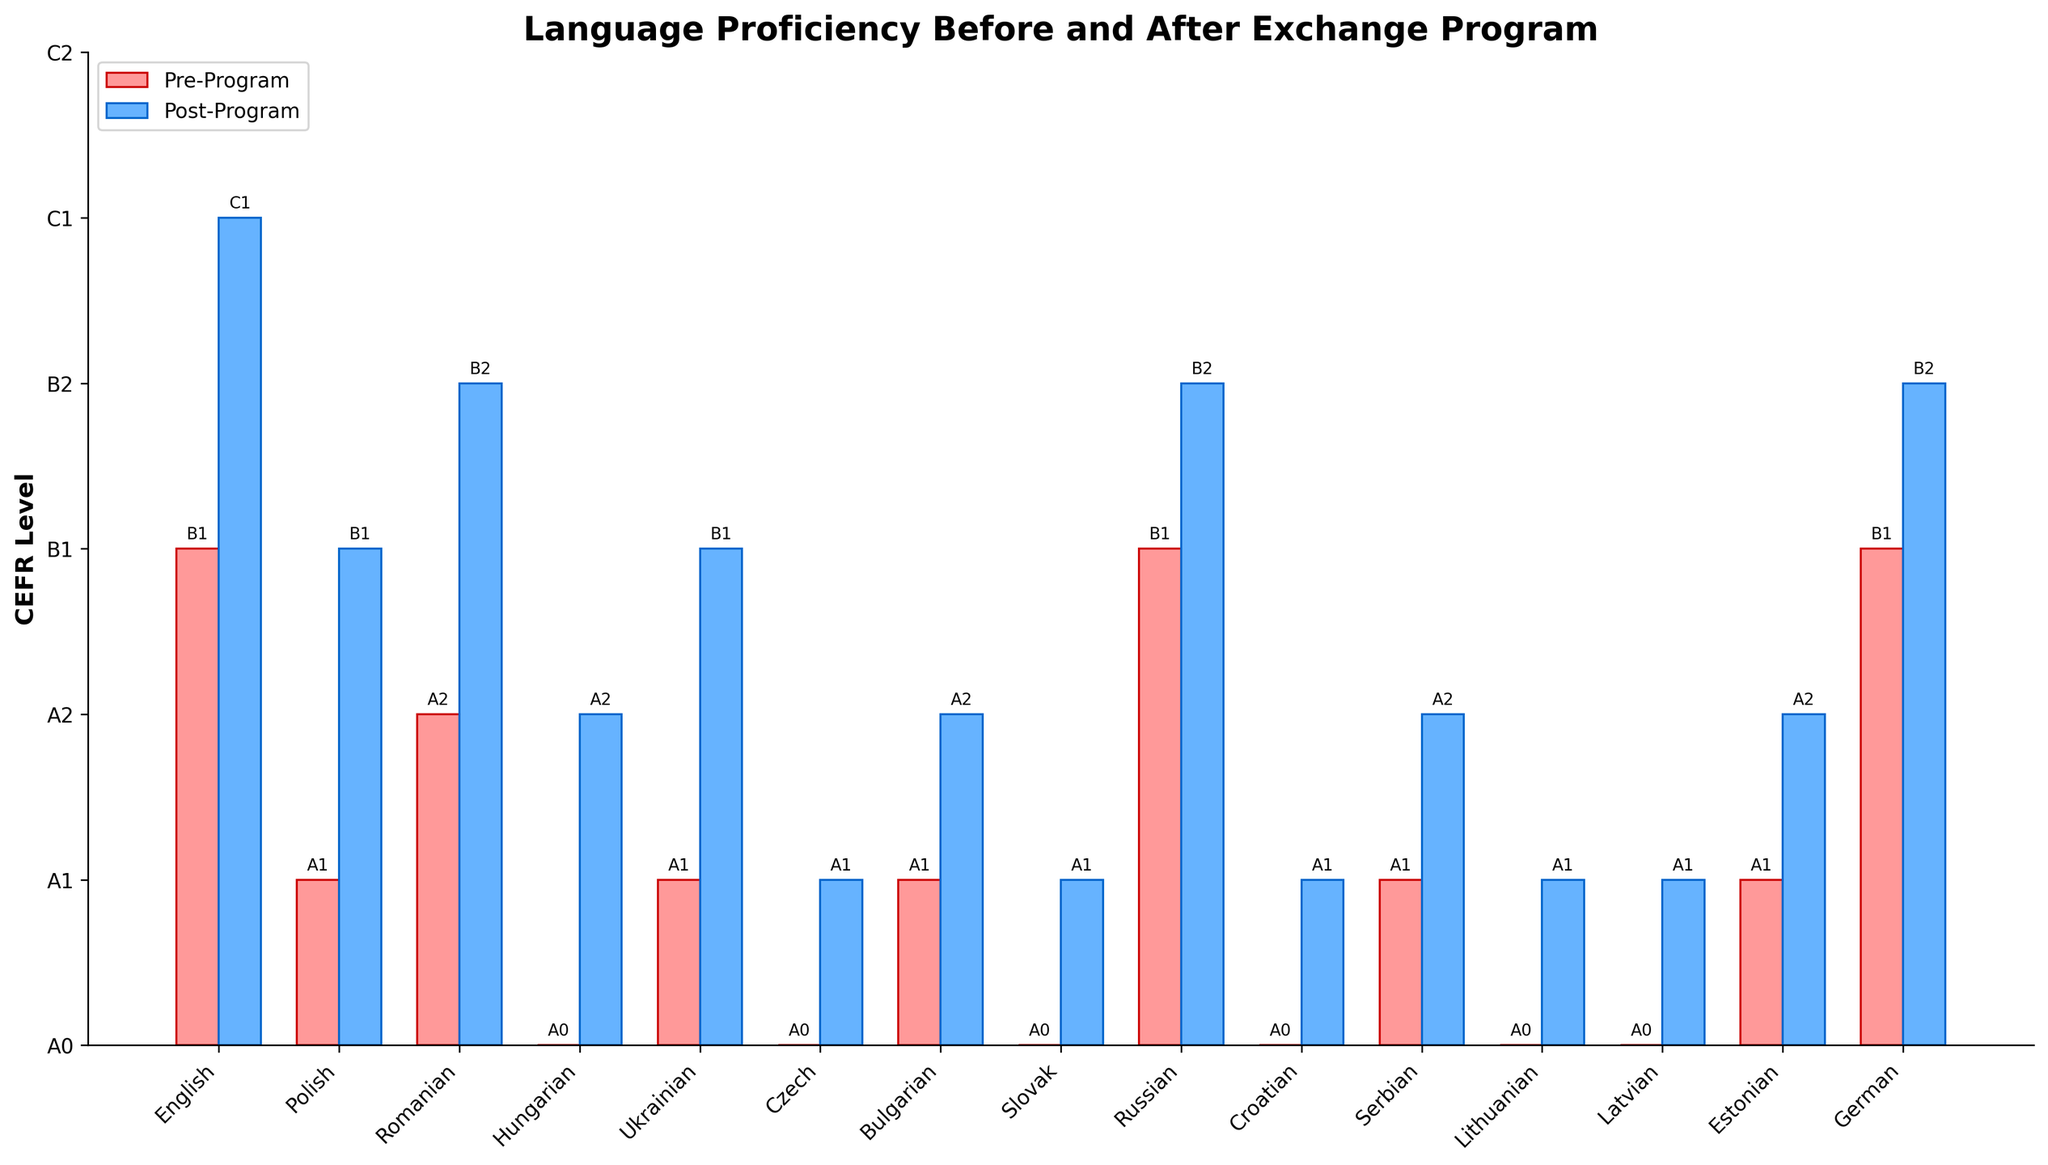Which language showed the greatest improvement in CEFR level after the program? The greatest improvement is found by comparing the difference in CEFR levels before and after the program for each language. Hungarian improved from A0 to A2, which is an increase of 2 levels. No other language shows a greater increase.
Answer: Hungarian What was the pre-program and post-program CEFR level for English? The pre-program level for English is B1 and the post-program level is C1. This can be directly observed from the figure's bars for English.
Answer: B1, C1 Which languages had a pre-program CEFR level of A0? The languages with a pre-program level of A0 can be identified from the bars marked at the lowest CEFR level (A0). These languages are Hungarian, Czech, Slovak, Croatian, Lithuanian, and Latvian.
Answer: Hungarian, Czech, Slovak, Croatian, Lithuanian, Latvian How many languages improved their CEFR level to at least B2 post-program? From the figure, post-program bars represent CEFR levels. Languages that reached at least B2 are English, Romanian, Russian, and German (their post-program levels are B2, B2, B2, and B2 respectively).
Answer: 4 Compare the CEFR levels of Polish and Ukrainian pre-program and post-program. Which one improved more? Polish improved from A1 to B1 (2 levels), while Ukrainian improved from A1 to B1 (2 levels). Both languages improved by the same amount.
Answer: Both improved equally What is the post-program CEFR level of German? From the figure, the post-program bar for German is marked at B2.
Answer: B2 How many languages had an increase of exactly one CEFR level? An increase of one level can be identified from the pre-program and post-program bars. These languages are Polish (A1 to B1), Ukrainian (A1 to B1), Bulgarian (A1 to A2), Czech (A0 to A1), Slovak (A0 to A1), Croatian (A0 to A1), Lithuanian (A0 to A1), Latvian (A0 to A1), Estonian (A1 to A2), Serbian (A1 to A2).
Answer: 10 What is the average post-program CEFR level for all languages? To find the average, convert the CEFR levels to numeric values (A0: 0, A1: 1, A2: 2, B1: 3, B2: 4, C1: 5). Sum the post-program numeric levels (5+3+4+2+3+1+2+1+4+1+2+1+1+2+4 = 36) and divide by the number of languages (15). The average numeric value is 36/15 = 2.4, corresponding to CEFR level slightly above A2.
Answer: A2/B1 Which language had the lowest pre-program CEFR level and what was its post-program level? By looking at bars reaching the lowest point on the pre-program scale (A0), Hungarian had the lowest pre-program level. Its post-program level is A2.
Answer: Hungarian, A2 